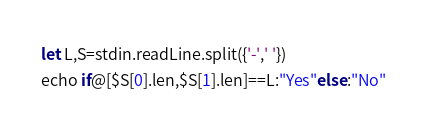<code> <loc_0><loc_0><loc_500><loc_500><_Nim_>let L,S=stdin.readLine.split({'-',' '})
echo if@[$S[0].len,$S[1].len]==L:"Yes"else:"No"</code> 